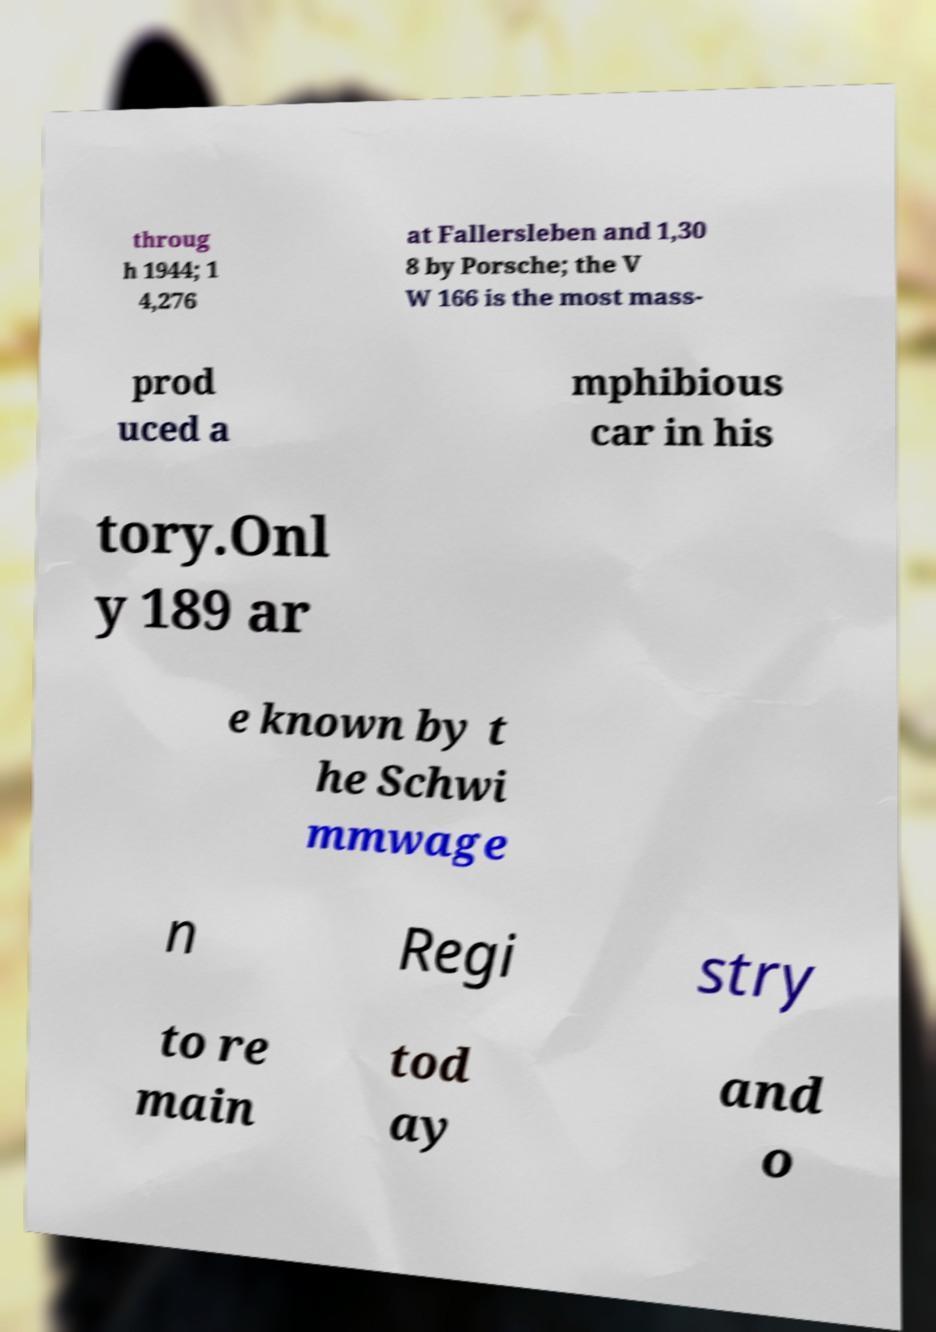Can you accurately transcribe the text from the provided image for me? throug h 1944; 1 4,276 at Fallersleben and 1,30 8 by Porsche; the V W 166 is the most mass- prod uced a mphibious car in his tory.Onl y 189 ar e known by t he Schwi mmwage n Regi stry to re main tod ay and o 